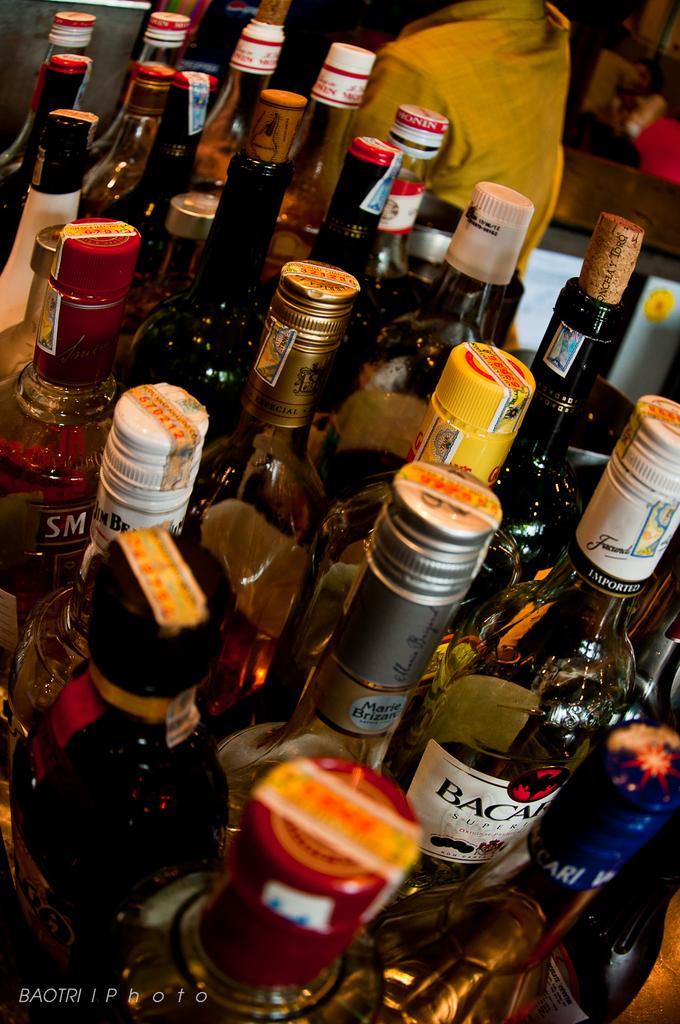In one or two sentences, can you explain what this image depicts? The image consists of number of wine bottles in it. At the background there is a person. 